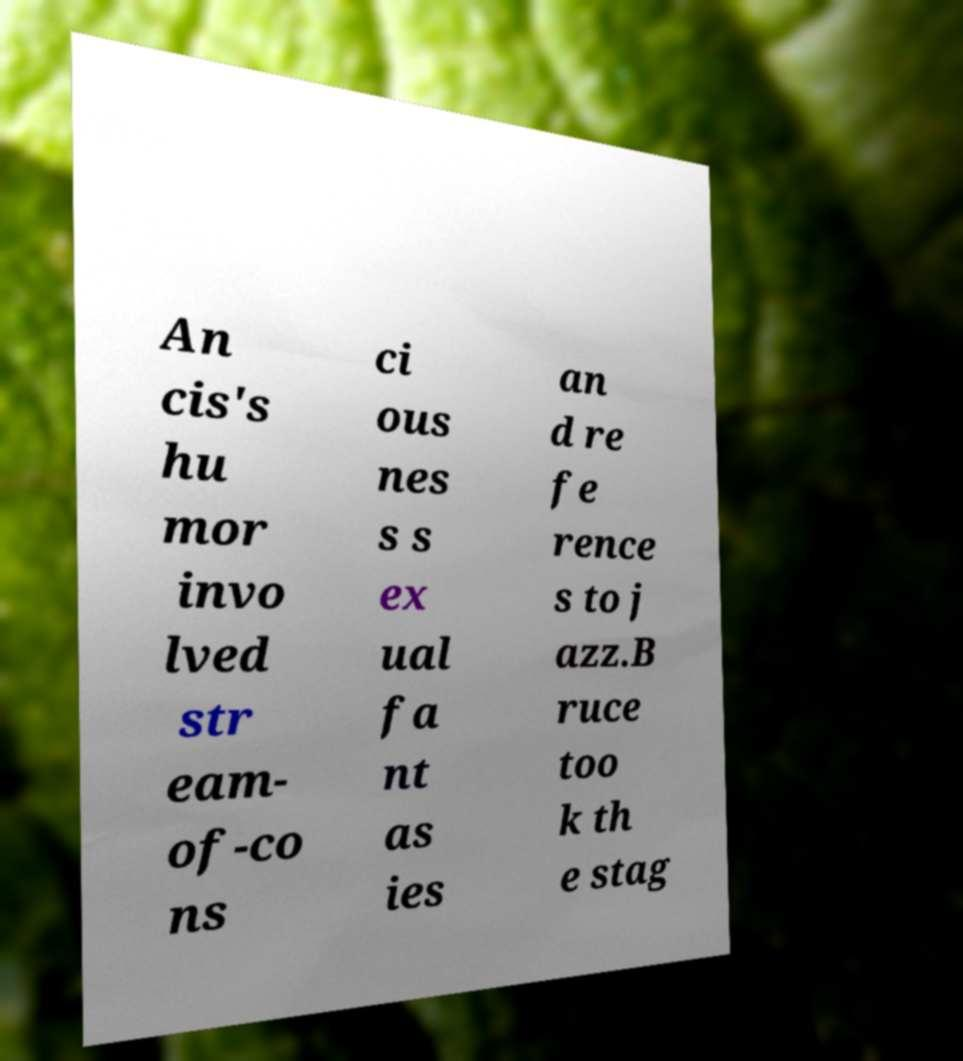Please identify and transcribe the text found in this image. An cis's hu mor invo lved str eam- of-co ns ci ous nes s s ex ual fa nt as ies an d re fe rence s to j azz.B ruce too k th e stag 